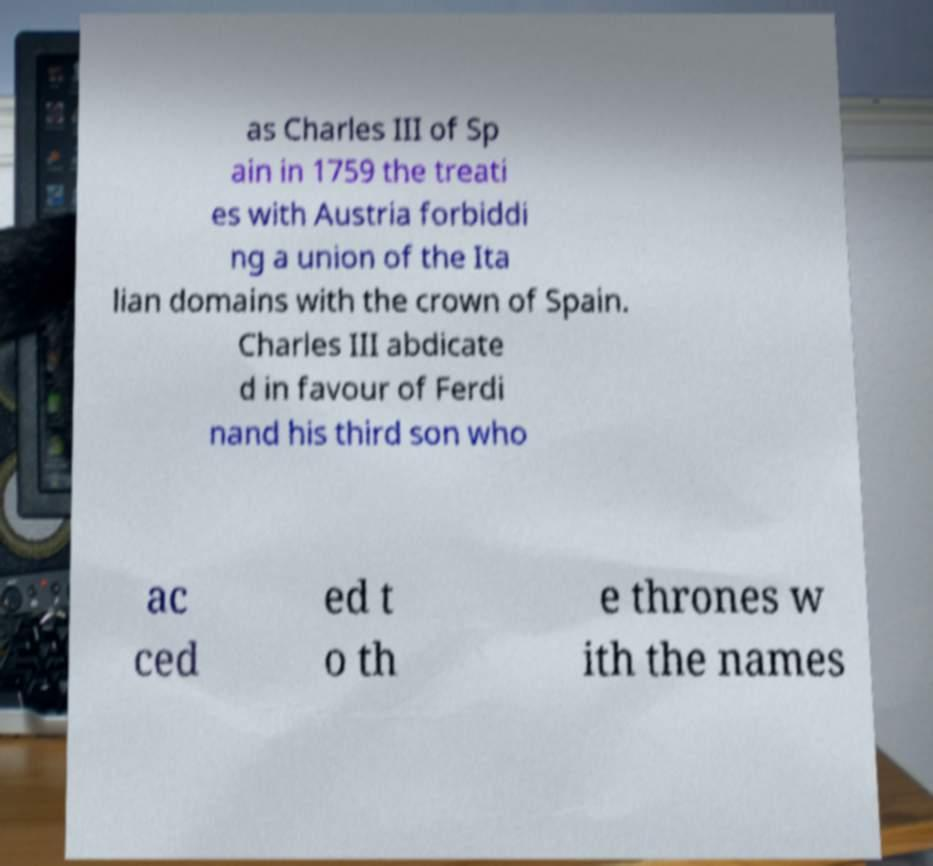Could you assist in decoding the text presented in this image and type it out clearly? as Charles III of Sp ain in 1759 the treati es with Austria forbiddi ng a union of the Ita lian domains with the crown of Spain. Charles III abdicate d in favour of Ferdi nand his third son who ac ced ed t o th e thrones w ith the names 